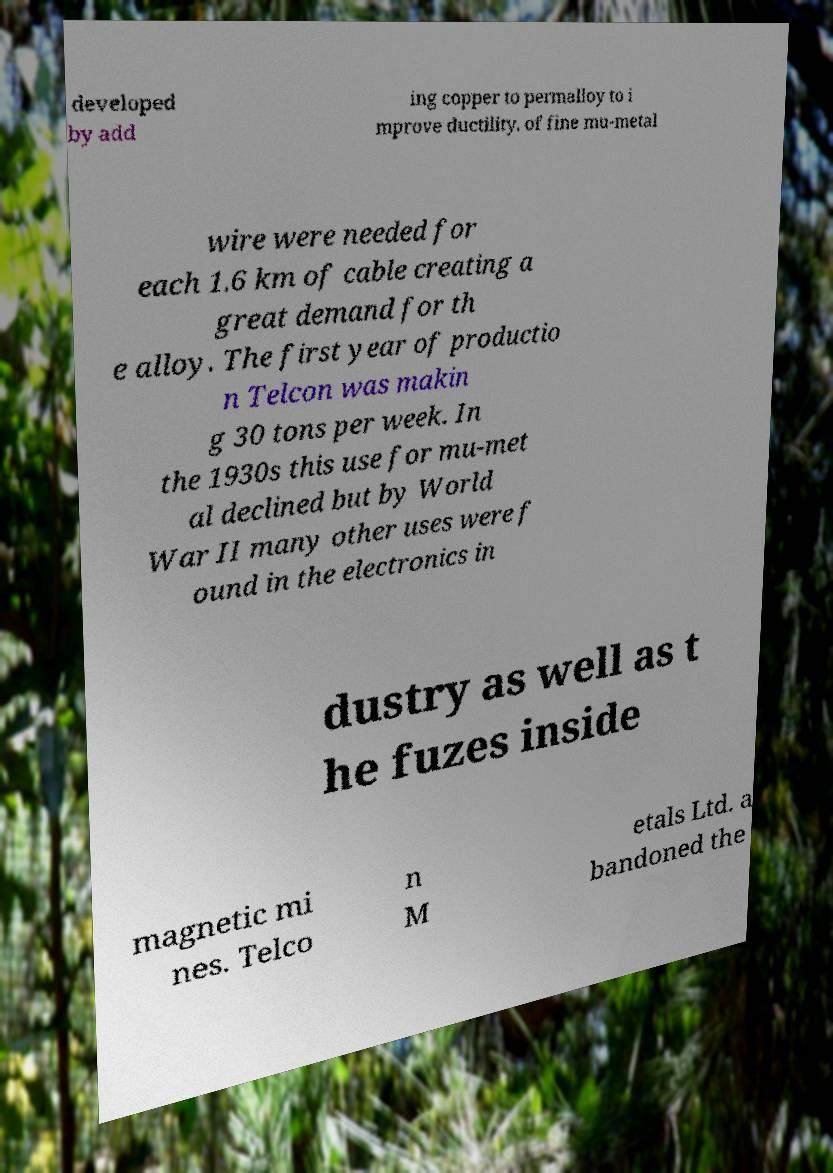Can you accurately transcribe the text from the provided image for me? developed by add ing copper to permalloy to i mprove ductility. of fine mu-metal wire were needed for each 1.6 km of cable creating a great demand for th e alloy. The first year of productio n Telcon was makin g 30 tons per week. In the 1930s this use for mu-met al declined but by World War II many other uses were f ound in the electronics in dustry as well as t he fuzes inside magnetic mi nes. Telco n M etals Ltd. a bandoned the 